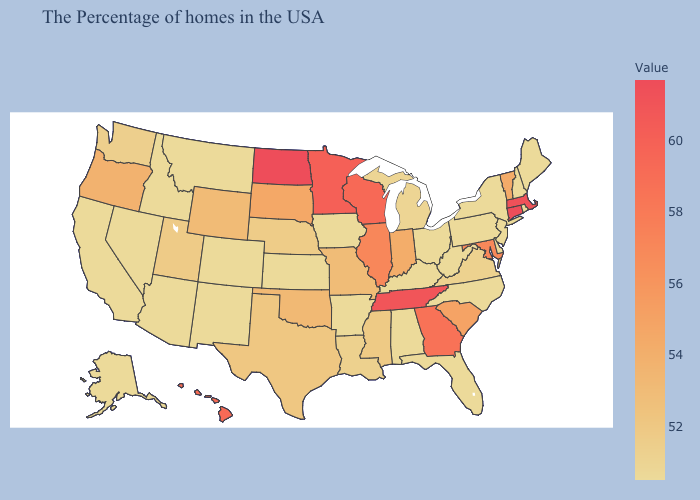Among the states that border Vermont , does New Hampshire have the lowest value?
Concise answer only. Yes. Among the states that border Florida , which have the highest value?
Give a very brief answer. Georgia. Does Iowa have a higher value than Utah?
Short answer required. No. Does Connecticut have the highest value in the Northeast?
Short answer required. Yes. Does Maine have a lower value than Minnesota?
Write a very short answer. Yes. Does the map have missing data?
Quick response, please. No. 